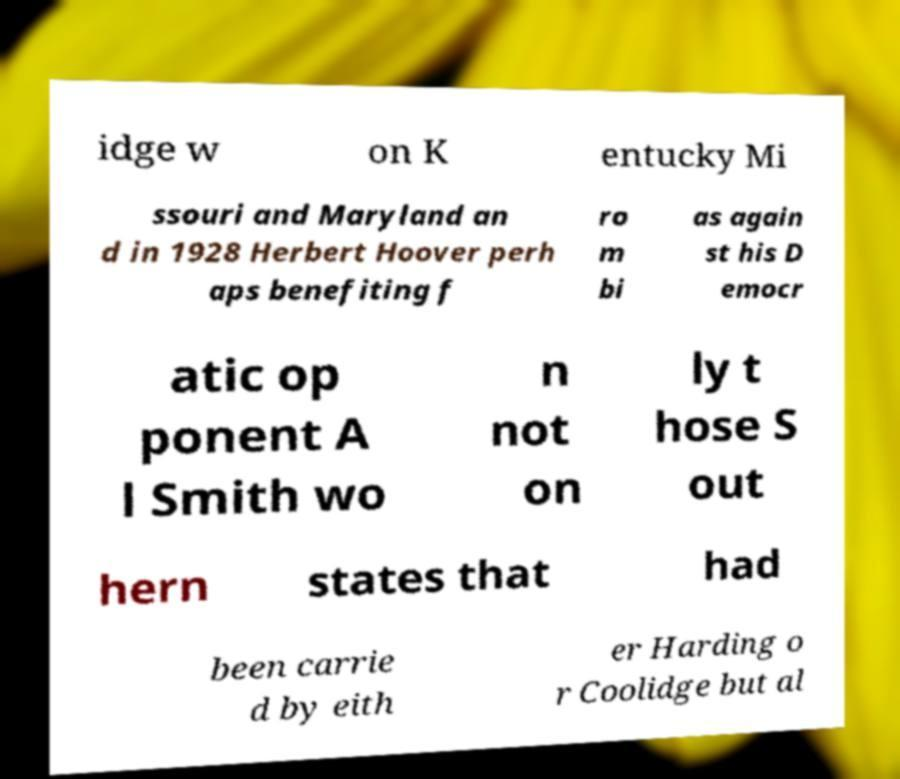Can you accurately transcribe the text from the provided image for me? idge w on K entucky Mi ssouri and Maryland an d in 1928 Herbert Hoover perh aps benefiting f ro m bi as again st his D emocr atic op ponent A l Smith wo n not on ly t hose S out hern states that had been carrie d by eith er Harding o r Coolidge but al 